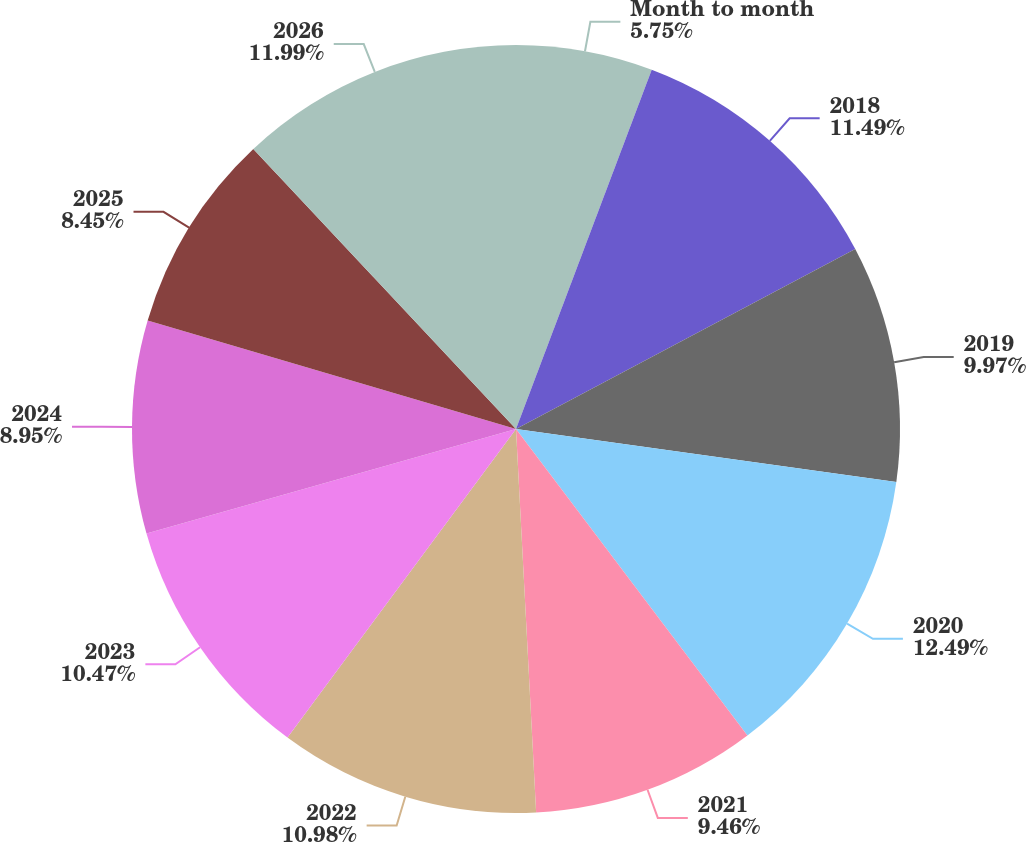Convert chart to OTSL. <chart><loc_0><loc_0><loc_500><loc_500><pie_chart><fcel>Month to month<fcel>2018<fcel>2019<fcel>2020<fcel>2021<fcel>2022<fcel>2023<fcel>2024<fcel>2025<fcel>2026<nl><fcel>5.75%<fcel>11.49%<fcel>9.97%<fcel>12.5%<fcel>9.46%<fcel>10.98%<fcel>10.47%<fcel>8.95%<fcel>8.45%<fcel>11.99%<nl></chart> 